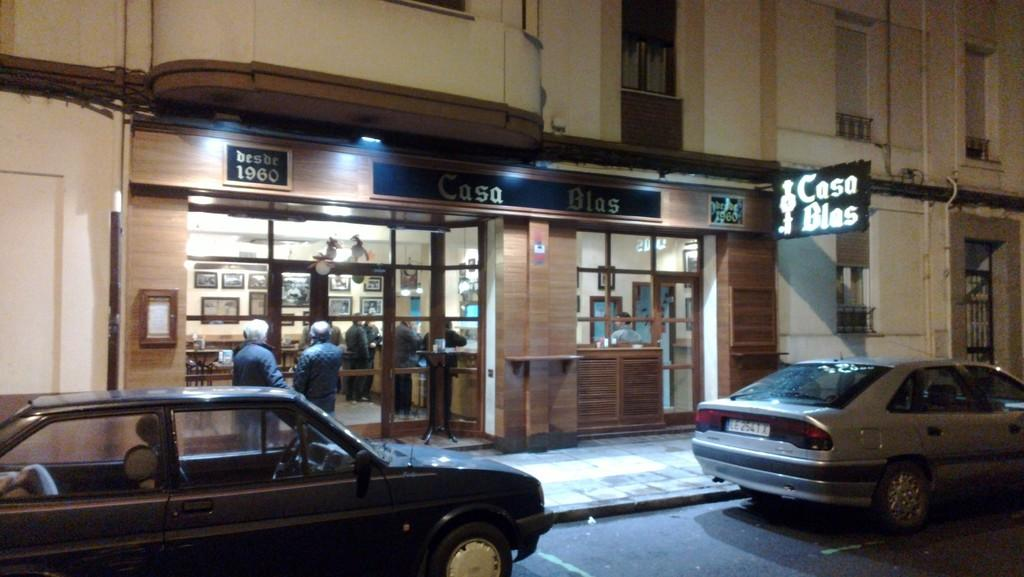How many cars are visible on the road in the image? There are two cars on the road in the image. What type of structure can be seen in the image? There is a building in the image. What objects are present in the image that are related to communication or display? There are boards and frames on the wall in the image. What objects are present in the image that are related to windows or vision? There are windows and glasses in the image. What type of entrance is visible in the image? There is a door in the image. Are there any people present in the image? Yes, there are persons in the image. What month is it in the image? The month cannot be determined from the image, as it does not contain any information about the time or date. What type of agreement is being signed in the image? There is no agreement or signing activity present in the image. 